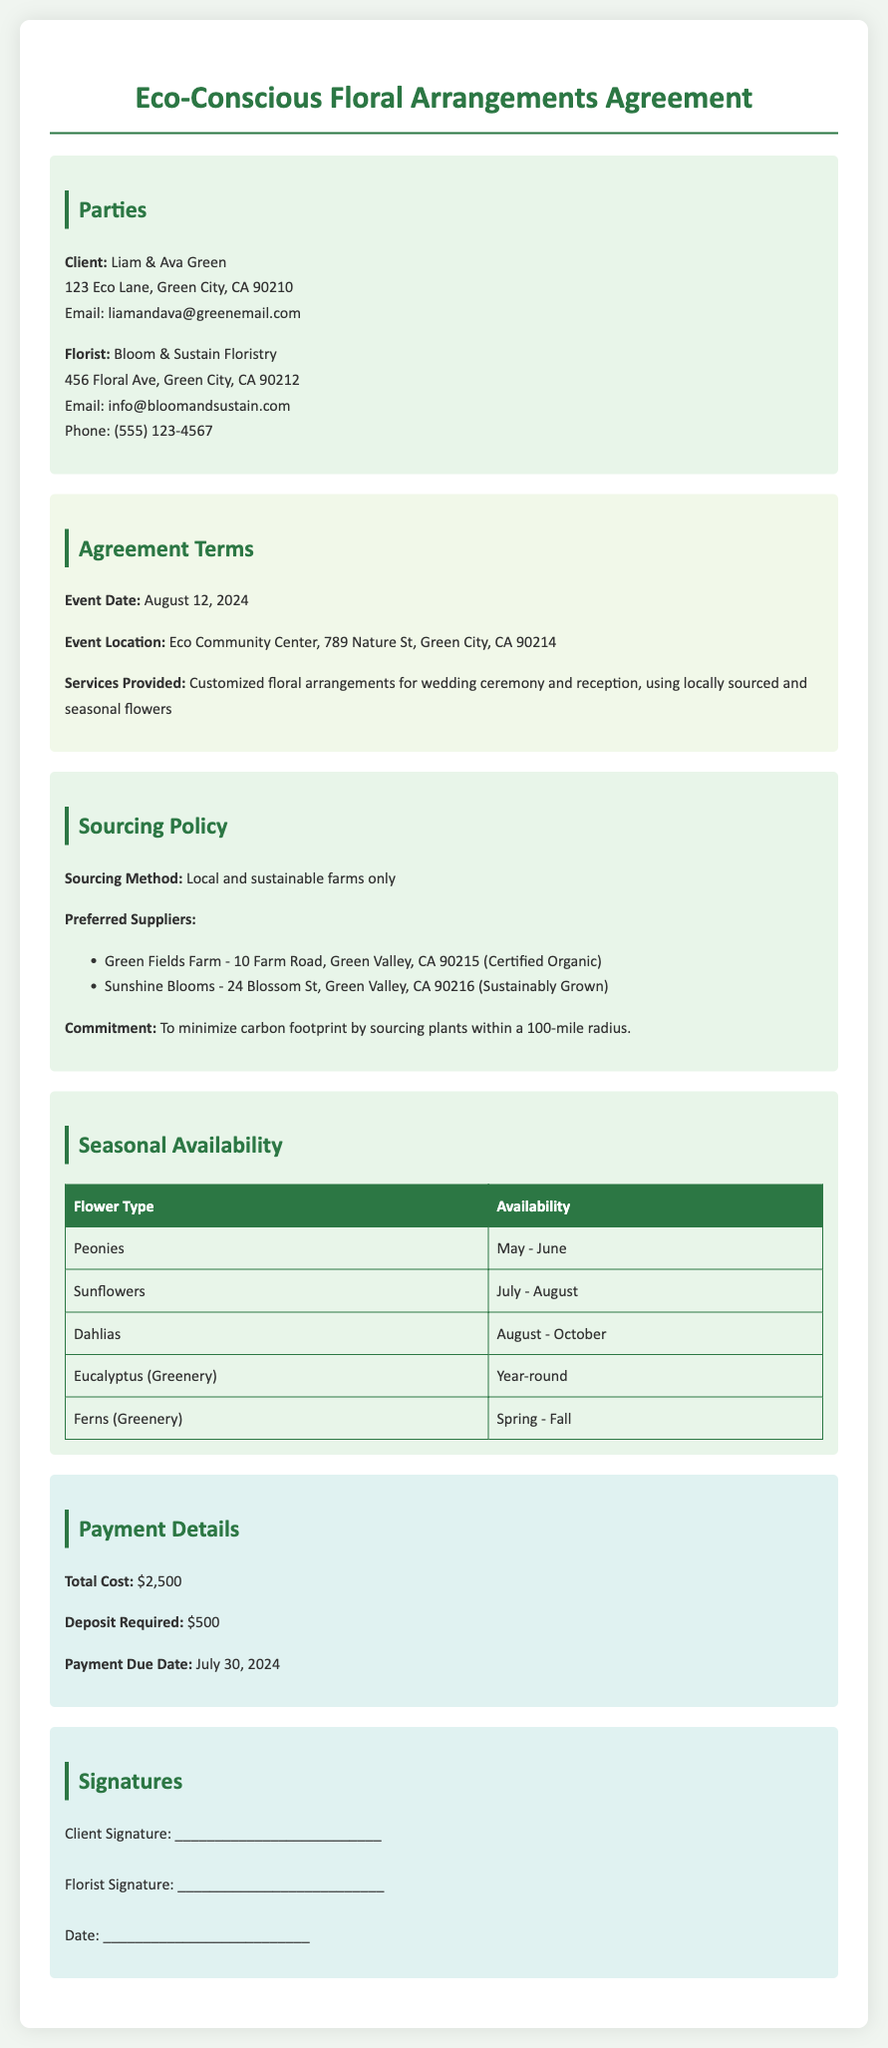what is the event date? The event date is specified in the agreement as August 12, 2024.
Answer: August 12, 2024 who are the parties involved in the agreement? The parties involved are the clients Liam & Ava Green and the florist Bloom & Sustain Floristry.
Answer: Liam & Ava Green and Bloom & Sustain Floristry what is the total cost for the floral arrangements? The total cost for the floral arrangements is indicated as $2,500.
Answer: $2,500 what is the sourcing method mentioned in the document? The sourcing method is detailed as using local and sustainable farms only.
Answer: Local and sustainable farms only which flower type is available year-round? The table lists Eucalyptus as the flower type available year-round.
Answer: Eucalyptus how much is the deposit required? The document states that a deposit of $500 is required.
Answer: $500 what is the commitment made regarding sourcing? The document commits to minimizing the carbon footprint by sourcing within a 100-mile radius.
Answer: Sourcing within a 100-mile radius which two suppliers are preferred for sourcing flowers? The suppliers listed are Green Fields Farm and Sunshine Blooms.
Answer: Green Fields Farm and Sunshine Blooms when is the payment due date? The agreement specifies that the payment is due on July 30, 2024.
Answer: July 30, 2024 what type of event is being planned? The agreement refers to a wedding ceremony and reception.
Answer: Wedding ceremony and reception 